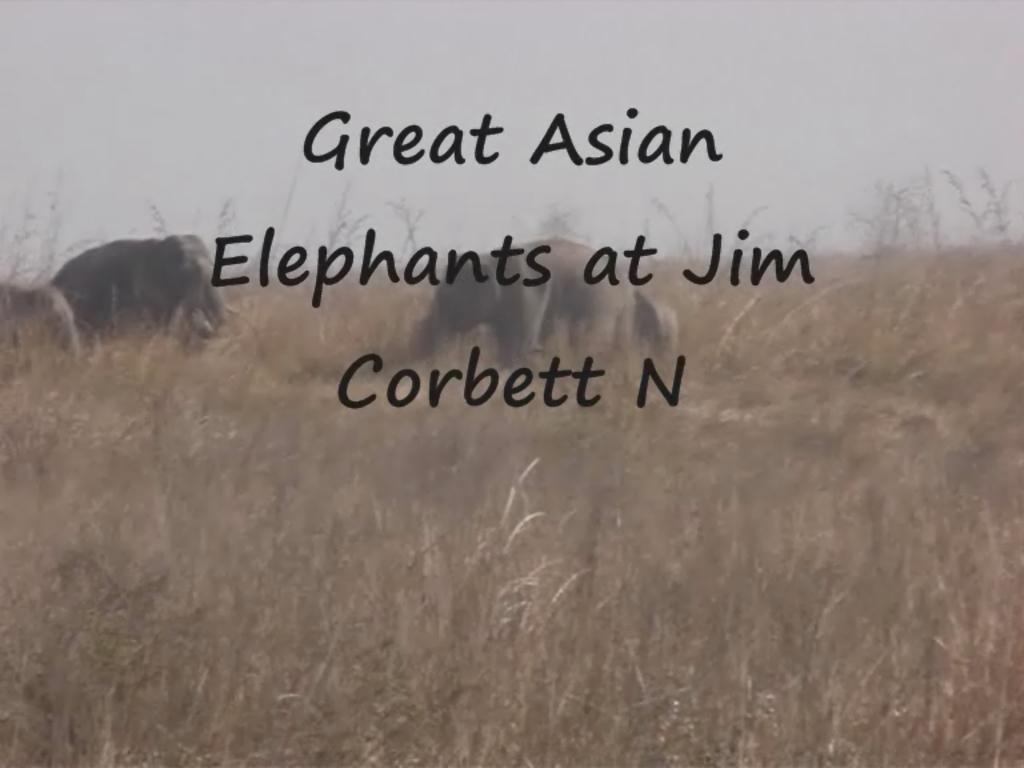What animals can be seen in the image? There are elephants walking in the image. What type of vegetation is present in the image? There is grass in the image. What can be seen in the background of the image? The sky is visible in the background of the image. Are there any visible marks or imperfections on the image? Yes, there are watermarks on the image. What type of tub can be seen in the image? There is no tub present in the image; it features elephants walking in a grassy area with a visible sky in the background. 